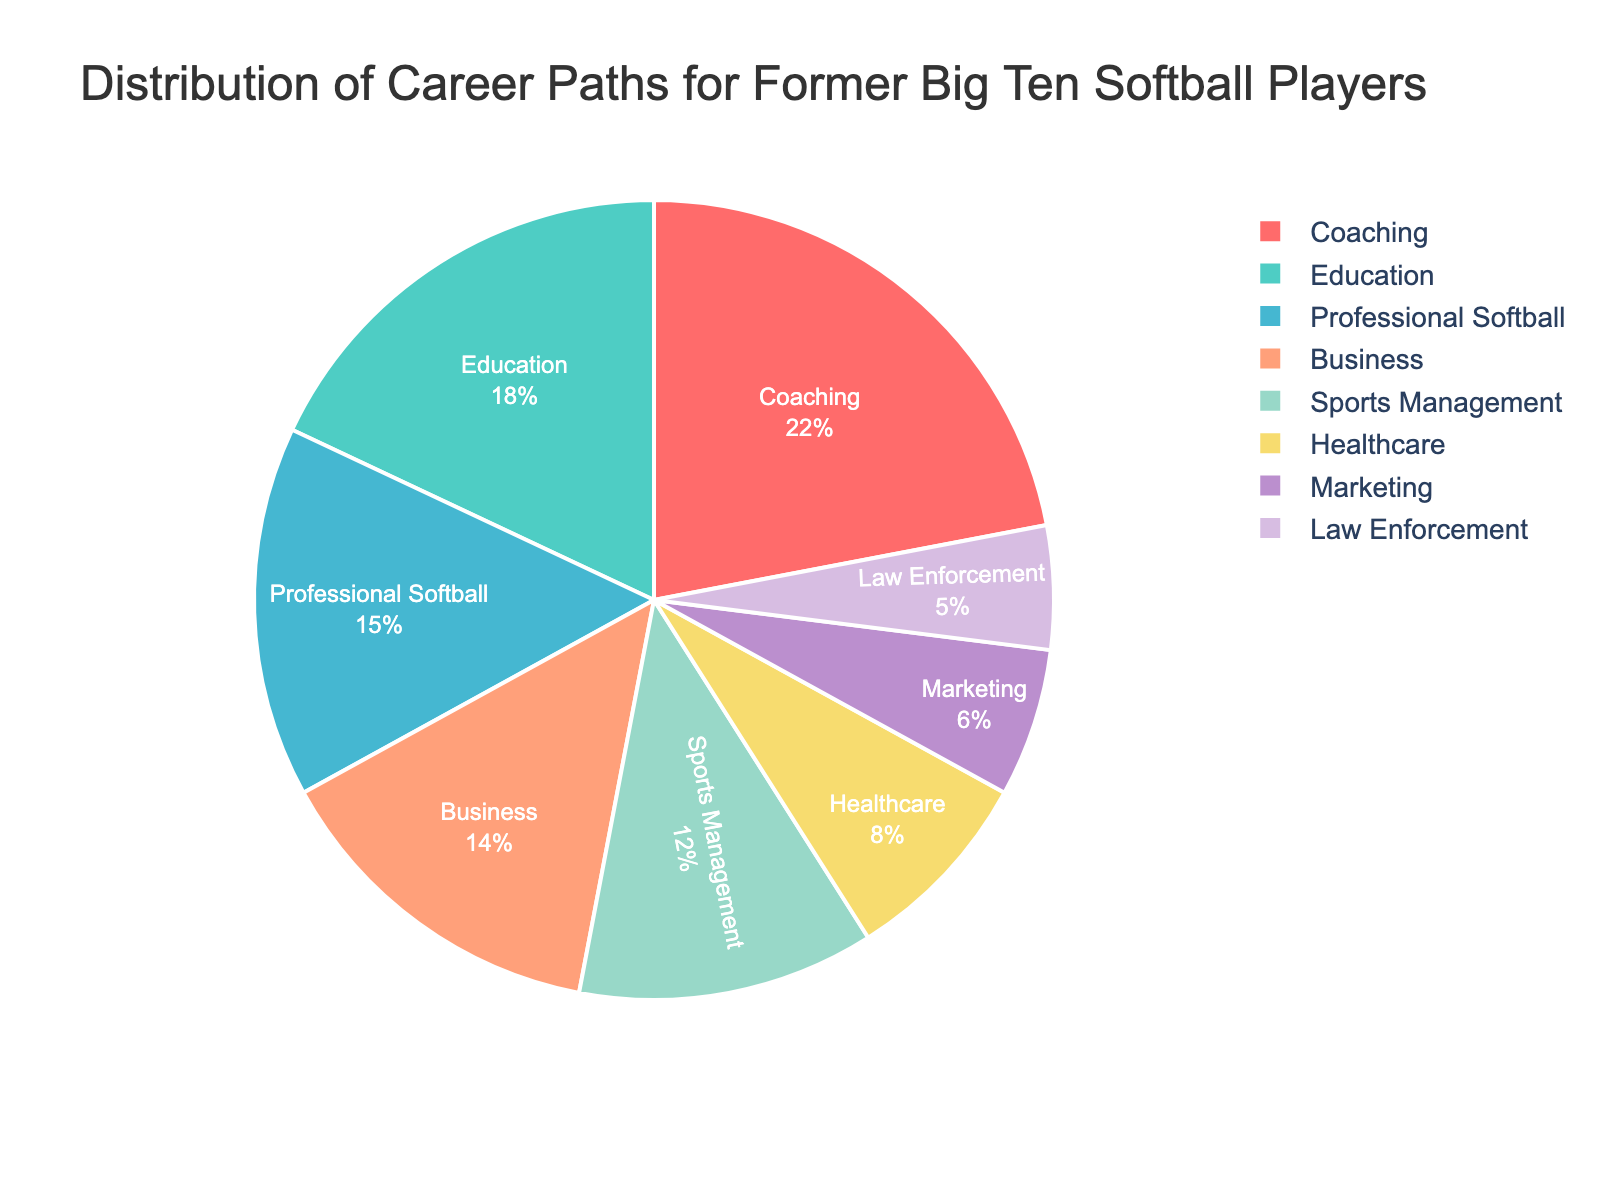Which career path has the highest percentage? The pie chart shows that Coaching has the largest section visually. The percentage for Coaching is 22%.
Answer: Coaching Which career path has the lowest percentage? The smallest section in the pie chart corresponds to Law Enforcement, which has a percentage of 5%.
Answer: Law Enforcement How much larger is the percentage for Coaching compared to Education? Coaching has a percentage of 22%, and Education has 18%. The difference is 22% - 18% = 4%.
Answer: 4% Sum up the percentages for Professional Softball, Education, and Business. Professional Softball is 15%, Education is 18%, and Business is 14%. Their sum is 15% + 18% + 14% = 47%.
Answer: 47% What is the percentage difference between the top two career paths? The top two career paths are Coaching (22%) and Education (18%). The difference is 22% - 18% = 4%.
Answer: 4% Which section is colored blue, and what is its percentage? The section colored blue corresponds to Sports Management, with a percentage of 12%.
Answer: Sports Management, 12% Combine the percentages of Sports Management and Marketing. How does this compare to Healthcare? Sports Management is 12% and Marketing is 6%, their sum is 12% + 6% = 18%. Healthcare is 8%. The combined percentage of Sports Management and Marketing (18%) is larger than Healthcare (8%) by 18% - 8% = 10%.
Answer: 10% Which career paths have similar percentages, and how close are they? Business has 14%, Professional Softball has 15%, and Marketing has 6%. Business and Professional Softball are close with a difference of 1% (15% - 14%).
Answer: Business and Professional Softball, 1% 